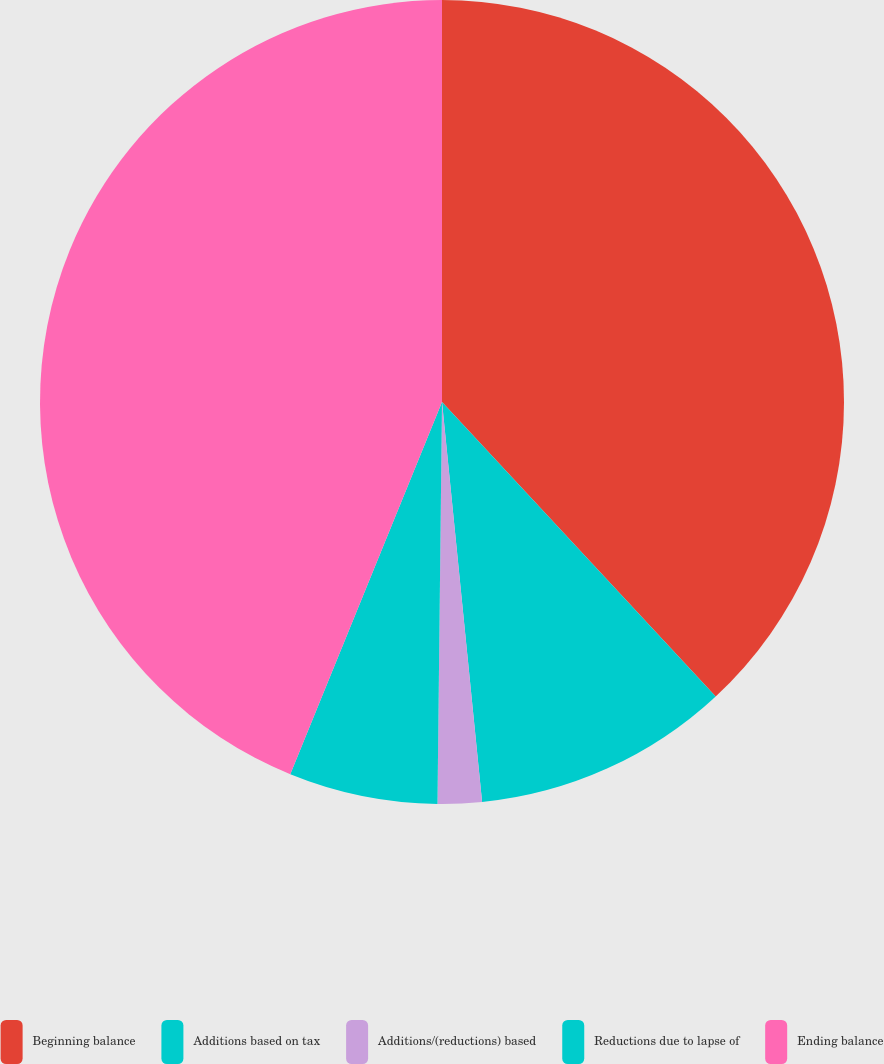<chart> <loc_0><loc_0><loc_500><loc_500><pie_chart><fcel>Beginning balance<fcel>Additions based on tax<fcel>Additions/(reductions) based<fcel>Reductions due to lapse of<fcel>Ending balance<nl><fcel>38.08%<fcel>10.33%<fcel>1.77%<fcel>5.98%<fcel>43.84%<nl></chart> 